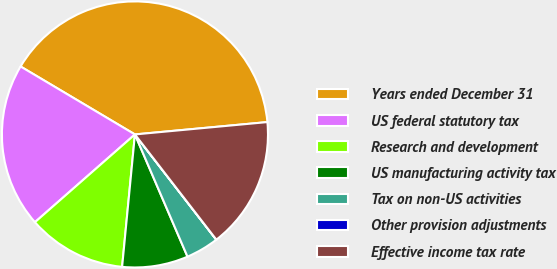Convert chart. <chart><loc_0><loc_0><loc_500><loc_500><pie_chart><fcel>Years ended December 31<fcel>US federal statutory tax<fcel>Research and development<fcel>US manufacturing activity tax<fcel>Tax on non-US activities<fcel>Other provision adjustments<fcel>Effective income tax rate<nl><fcel>39.99%<fcel>20.0%<fcel>12.0%<fcel>8.0%<fcel>4.01%<fcel>0.01%<fcel>16.0%<nl></chart> 